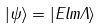Convert formula to latex. <formula><loc_0><loc_0><loc_500><loc_500>| \psi \rangle = | E l m \Lambda \rangle</formula> 